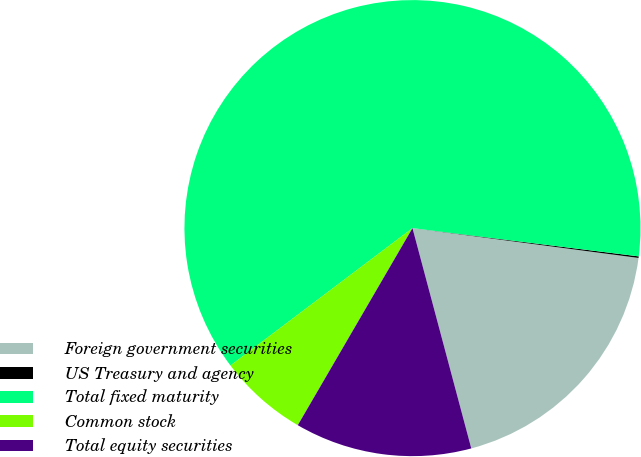<chart> <loc_0><loc_0><loc_500><loc_500><pie_chart><fcel>Foreign government securities<fcel>US Treasury and agency<fcel>Total fixed maturity<fcel>Common stock<fcel>Total equity securities<nl><fcel>18.76%<fcel>0.11%<fcel>62.27%<fcel>6.32%<fcel>12.54%<nl></chart> 